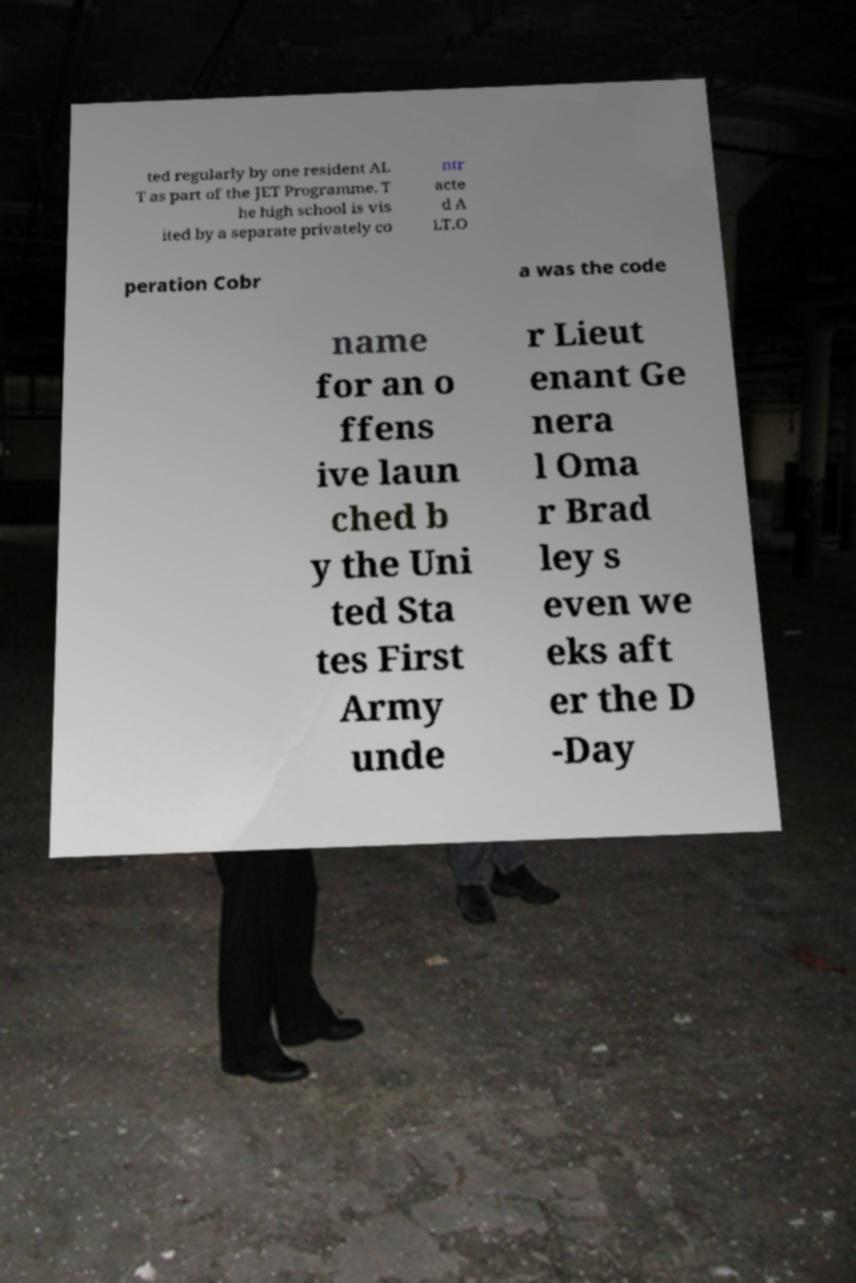I need the written content from this picture converted into text. Can you do that? ted regularly by one resident AL T as part of the JET Programme. T he high school is vis ited by a separate privately co ntr acte d A LT.O peration Cobr a was the code name for an o ffens ive laun ched b y the Uni ted Sta tes First Army unde r Lieut enant Ge nera l Oma r Brad ley s even we eks aft er the D -Day 